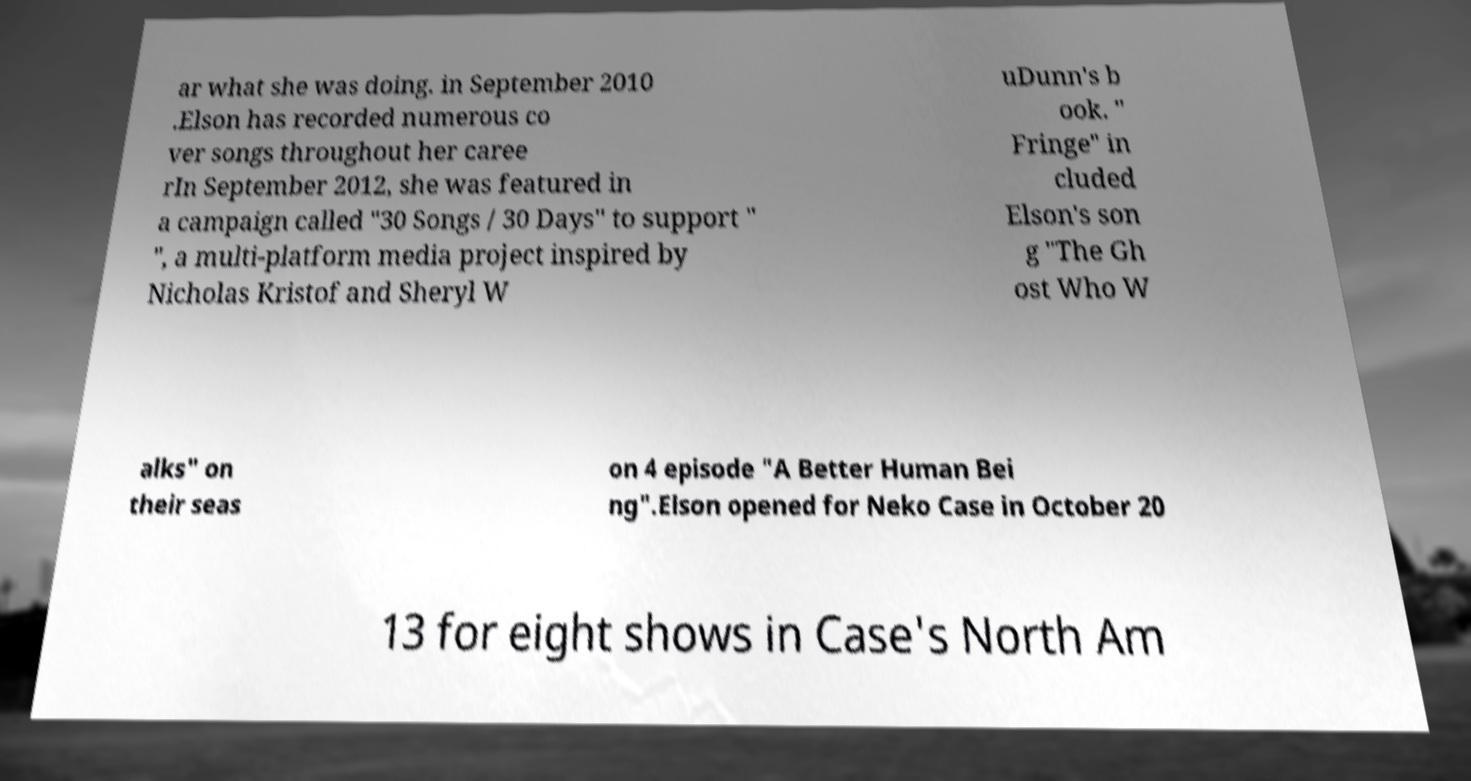There's text embedded in this image that I need extracted. Can you transcribe it verbatim? ar what she was doing. in September 2010 .Elson has recorded numerous co ver songs throughout her caree rIn September 2012, she was featured in a campaign called "30 Songs / 30 Days" to support " ", a multi-platform media project inspired by Nicholas Kristof and Sheryl W uDunn's b ook. " Fringe" in cluded Elson's son g "The Gh ost Who W alks" on their seas on 4 episode "A Better Human Bei ng".Elson opened for Neko Case in October 20 13 for eight shows in Case's North Am 